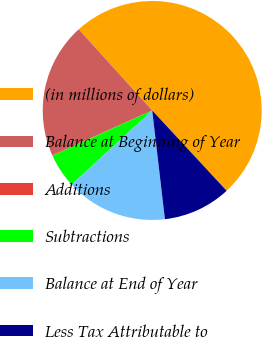Convert chart. <chart><loc_0><loc_0><loc_500><loc_500><pie_chart><fcel>(in millions of dollars)<fcel>Balance at Beginning of Year<fcel>Additions<fcel>Subtractions<fcel>Balance at End of Year<fcel>Less Tax Attributable to<nl><fcel>49.82%<fcel>19.98%<fcel>0.09%<fcel>5.06%<fcel>15.01%<fcel>10.04%<nl></chart> 